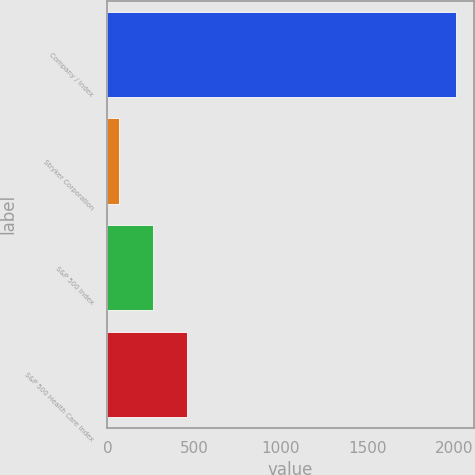Convert chart to OTSL. <chart><loc_0><loc_0><loc_500><loc_500><bar_chart><fcel>Company / Index<fcel>Stryker Corporation<fcel>S&P 500 Index<fcel>S&P 500 Health Care Index<nl><fcel>2011<fcel>69.32<fcel>263.49<fcel>457.66<nl></chart> 